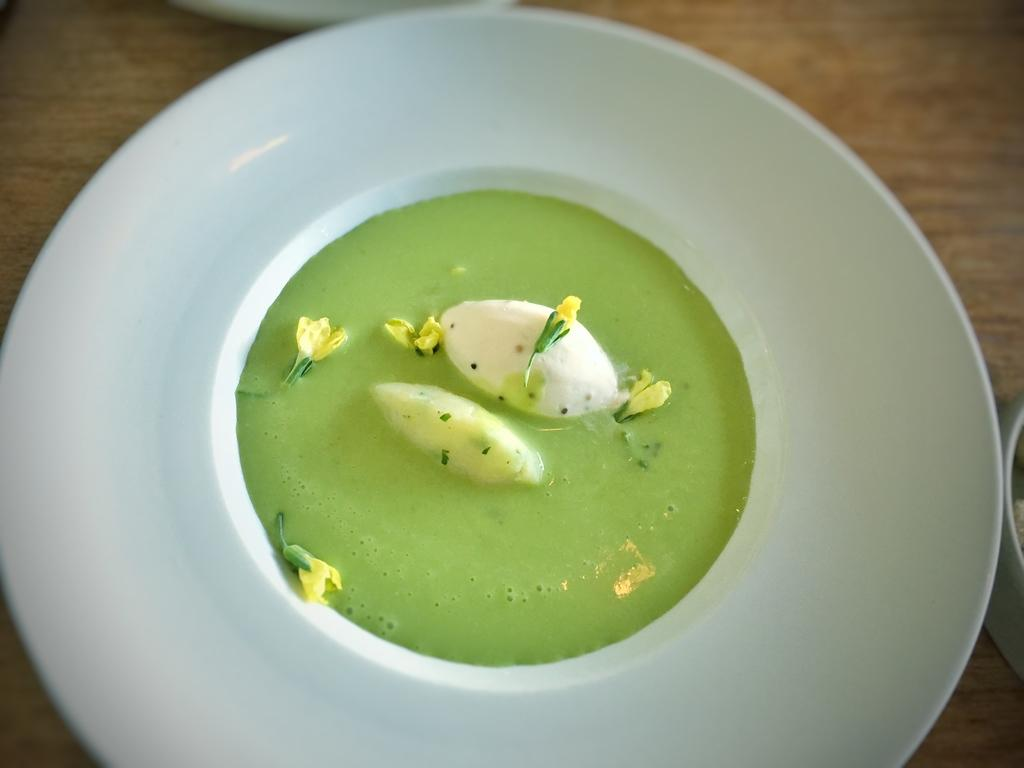What is the food in the image submerged in? The food is in a green liquid-like substance in the image. How is the food presented in the image? The food is on a platter. What is the platter placed on? The platter is placed on a wooden surface. Can you describe the white object in the image? There is a white object on the top of the platter or the image. What type of destruction can be seen happening to the food in the image? There is no destruction happening to the food in the image; it is presented on a platter. Can you tell me how many basketballs are visible in the image? There are no basketballs present in the image. 